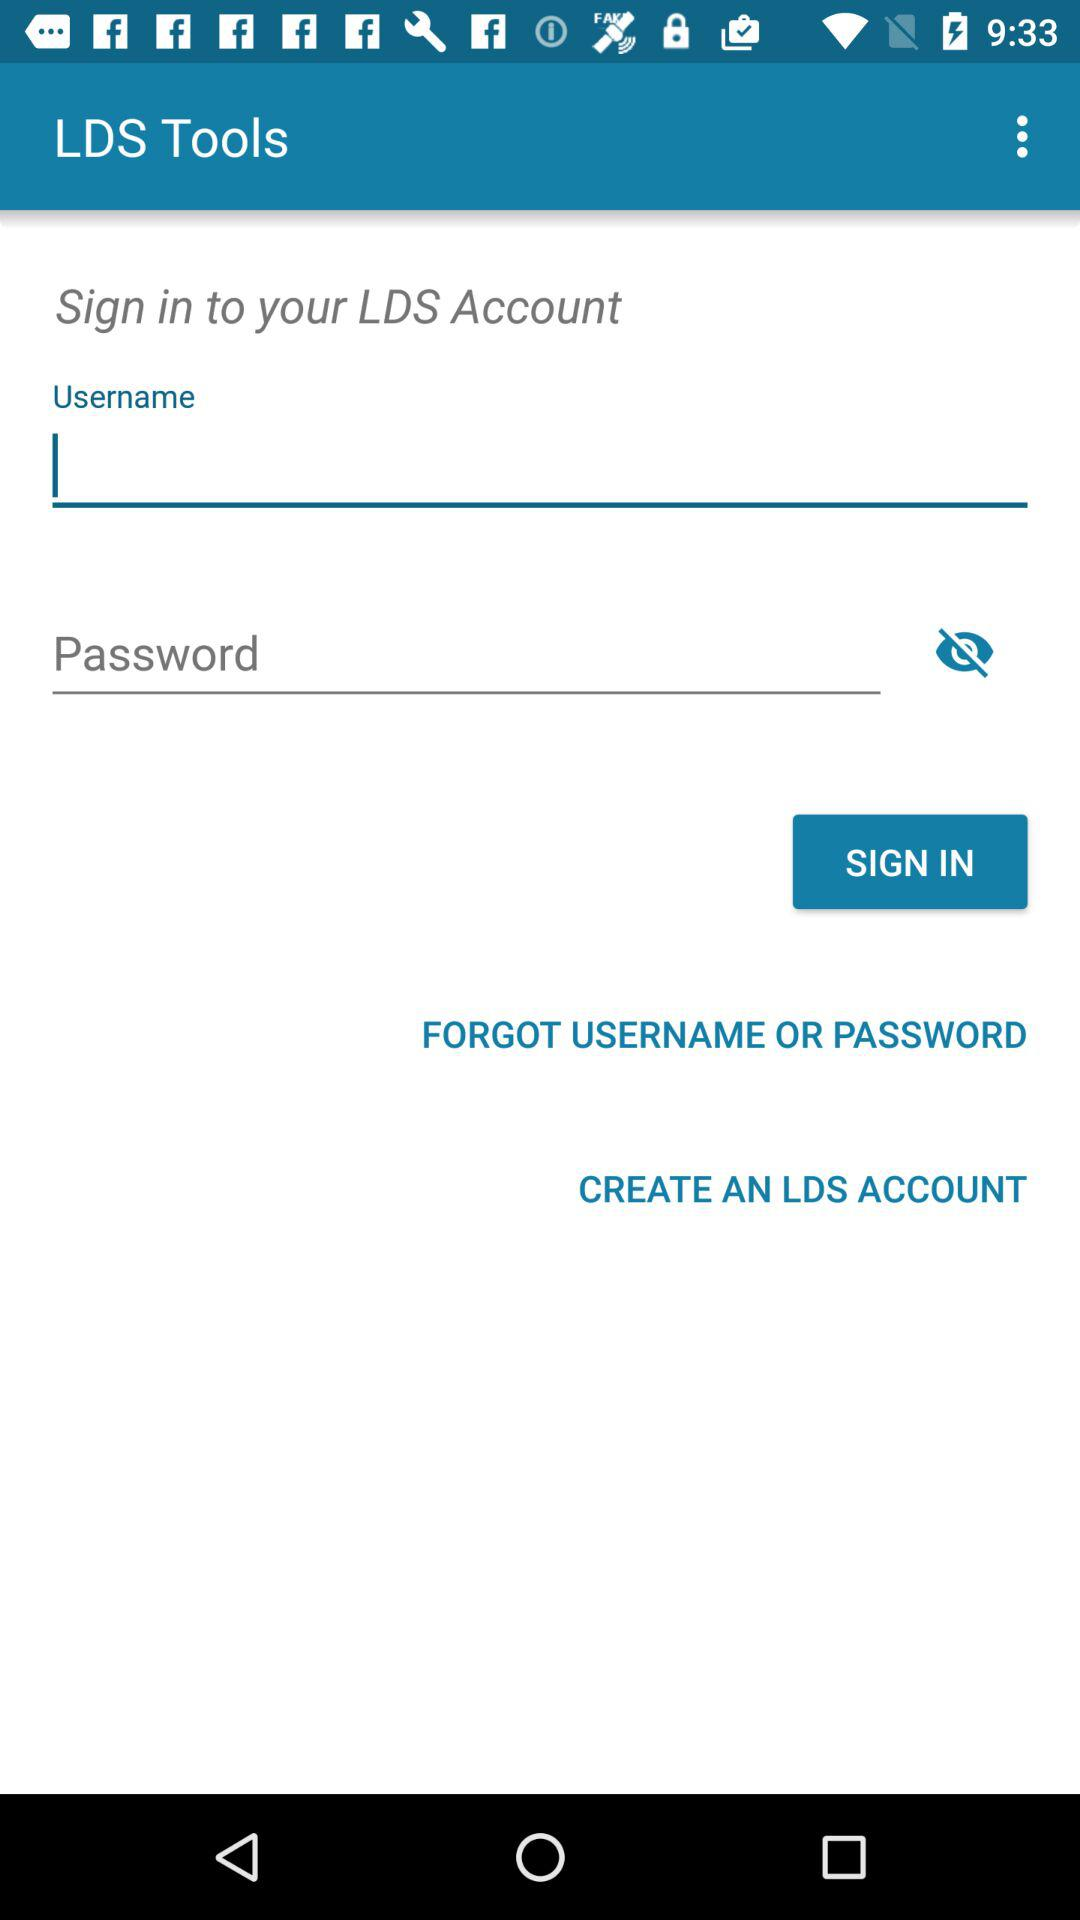How many input fields are there for signing in?
Answer the question using a single word or phrase. 2 